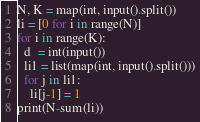Convert code to text. <code><loc_0><loc_0><loc_500><loc_500><_Python_>N, K = map(int, input().split())
li = [0 for i in range(N)]
for i in range(K):
  d  = int(input())
  li1 = list(map(int, input().split()))
  for j in li1:
    li[j-1] = 1
print(N-sum(li))</code> 